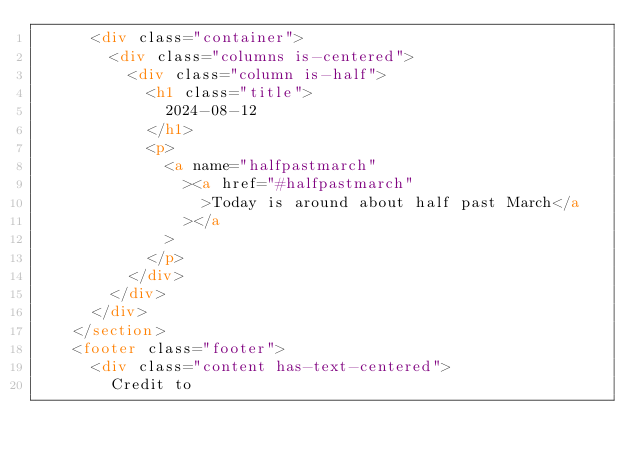<code> <loc_0><loc_0><loc_500><loc_500><_HTML_>      <div class="container">
        <div class="columns is-centered">
          <div class="column is-half">
            <h1 class="title">
              2024-08-12
            </h1>
            <p>
              <a name="halfpastmarch"
                ><a href="#halfpastmarch"
                  >Today is around about half past March</a
                ></a
              >
            </p>
          </div>
        </div>
      </div>
    </section>
    <footer class="footer">
      <div class="content has-text-centered">
        Credit to</code> 